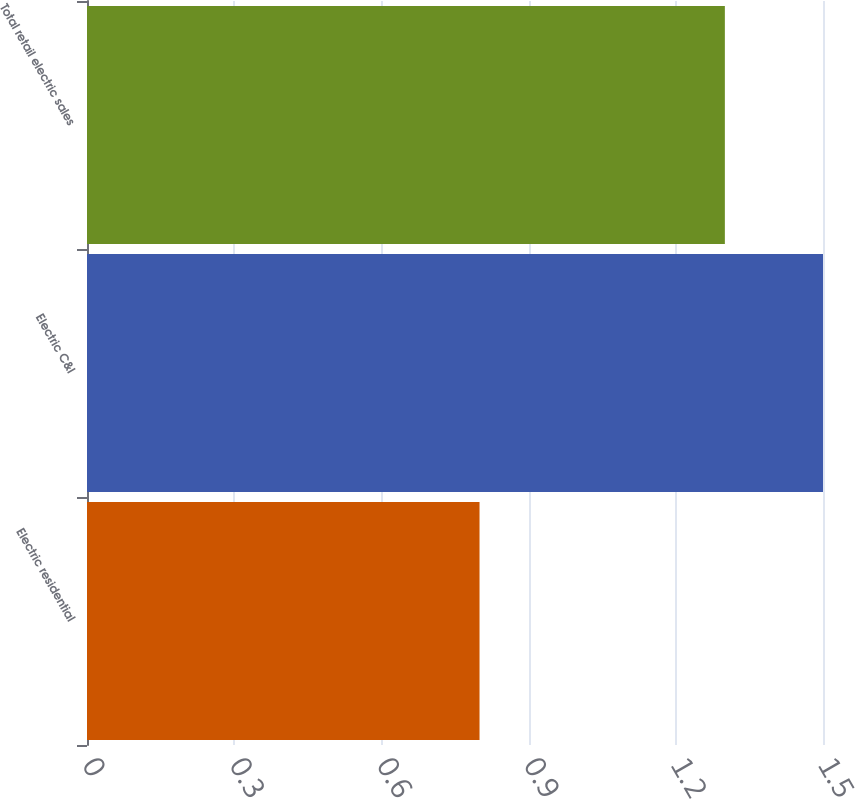Convert chart. <chart><loc_0><loc_0><loc_500><loc_500><bar_chart><fcel>Electric residential<fcel>Electric C&I<fcel>Total retail electric sales<nl><fcel>0.8<fcel>1.5<fcel>1.3<nl></chart> 